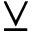Convert formula to latex. <formula><loc_0><loc_0><loc_500><loc_500>\veebar</formula> 